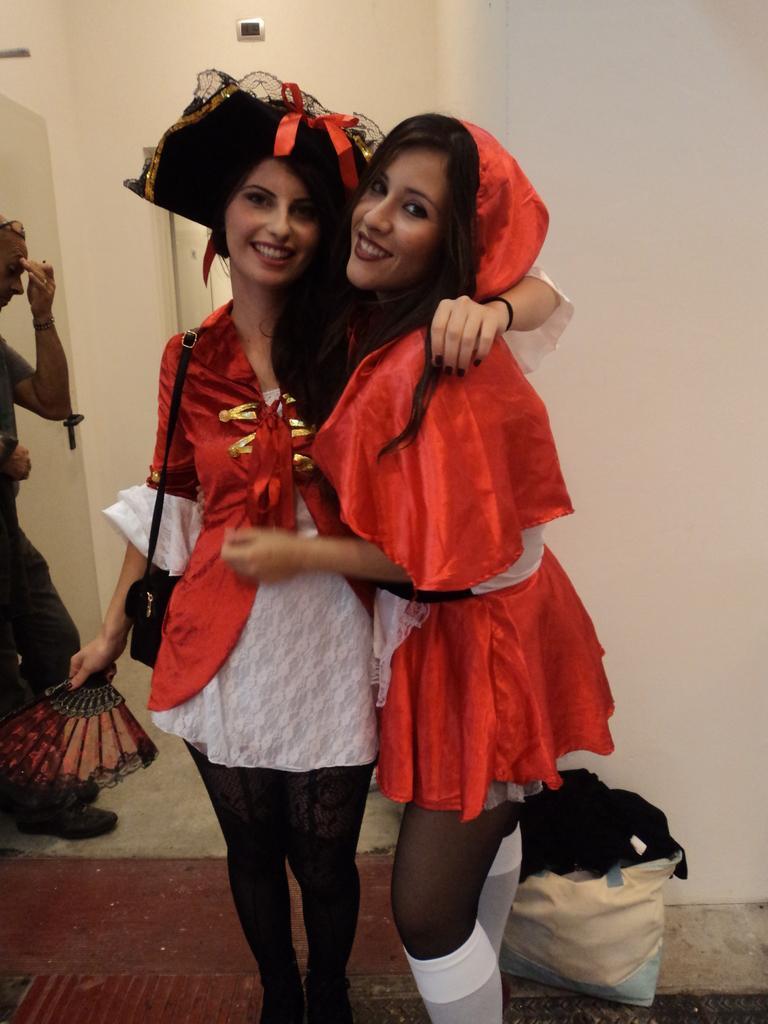Can you describe this image briefly? In the image we can see two women standing, wearing clothes and they are smiling. The left side woman is holding hand fan and carrying bag. Behind them there is a wall and another person walking. There is even a cover and the floor. 